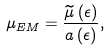Convert formula to latex. <formula><loc_0><loc_0><loc_500><loc_500>\mu _ { E M } = \frac { \widetilde { \mu } \left ( \epsilon \right ) } { a \left ( \epsilon \right ) } ,</formula> 